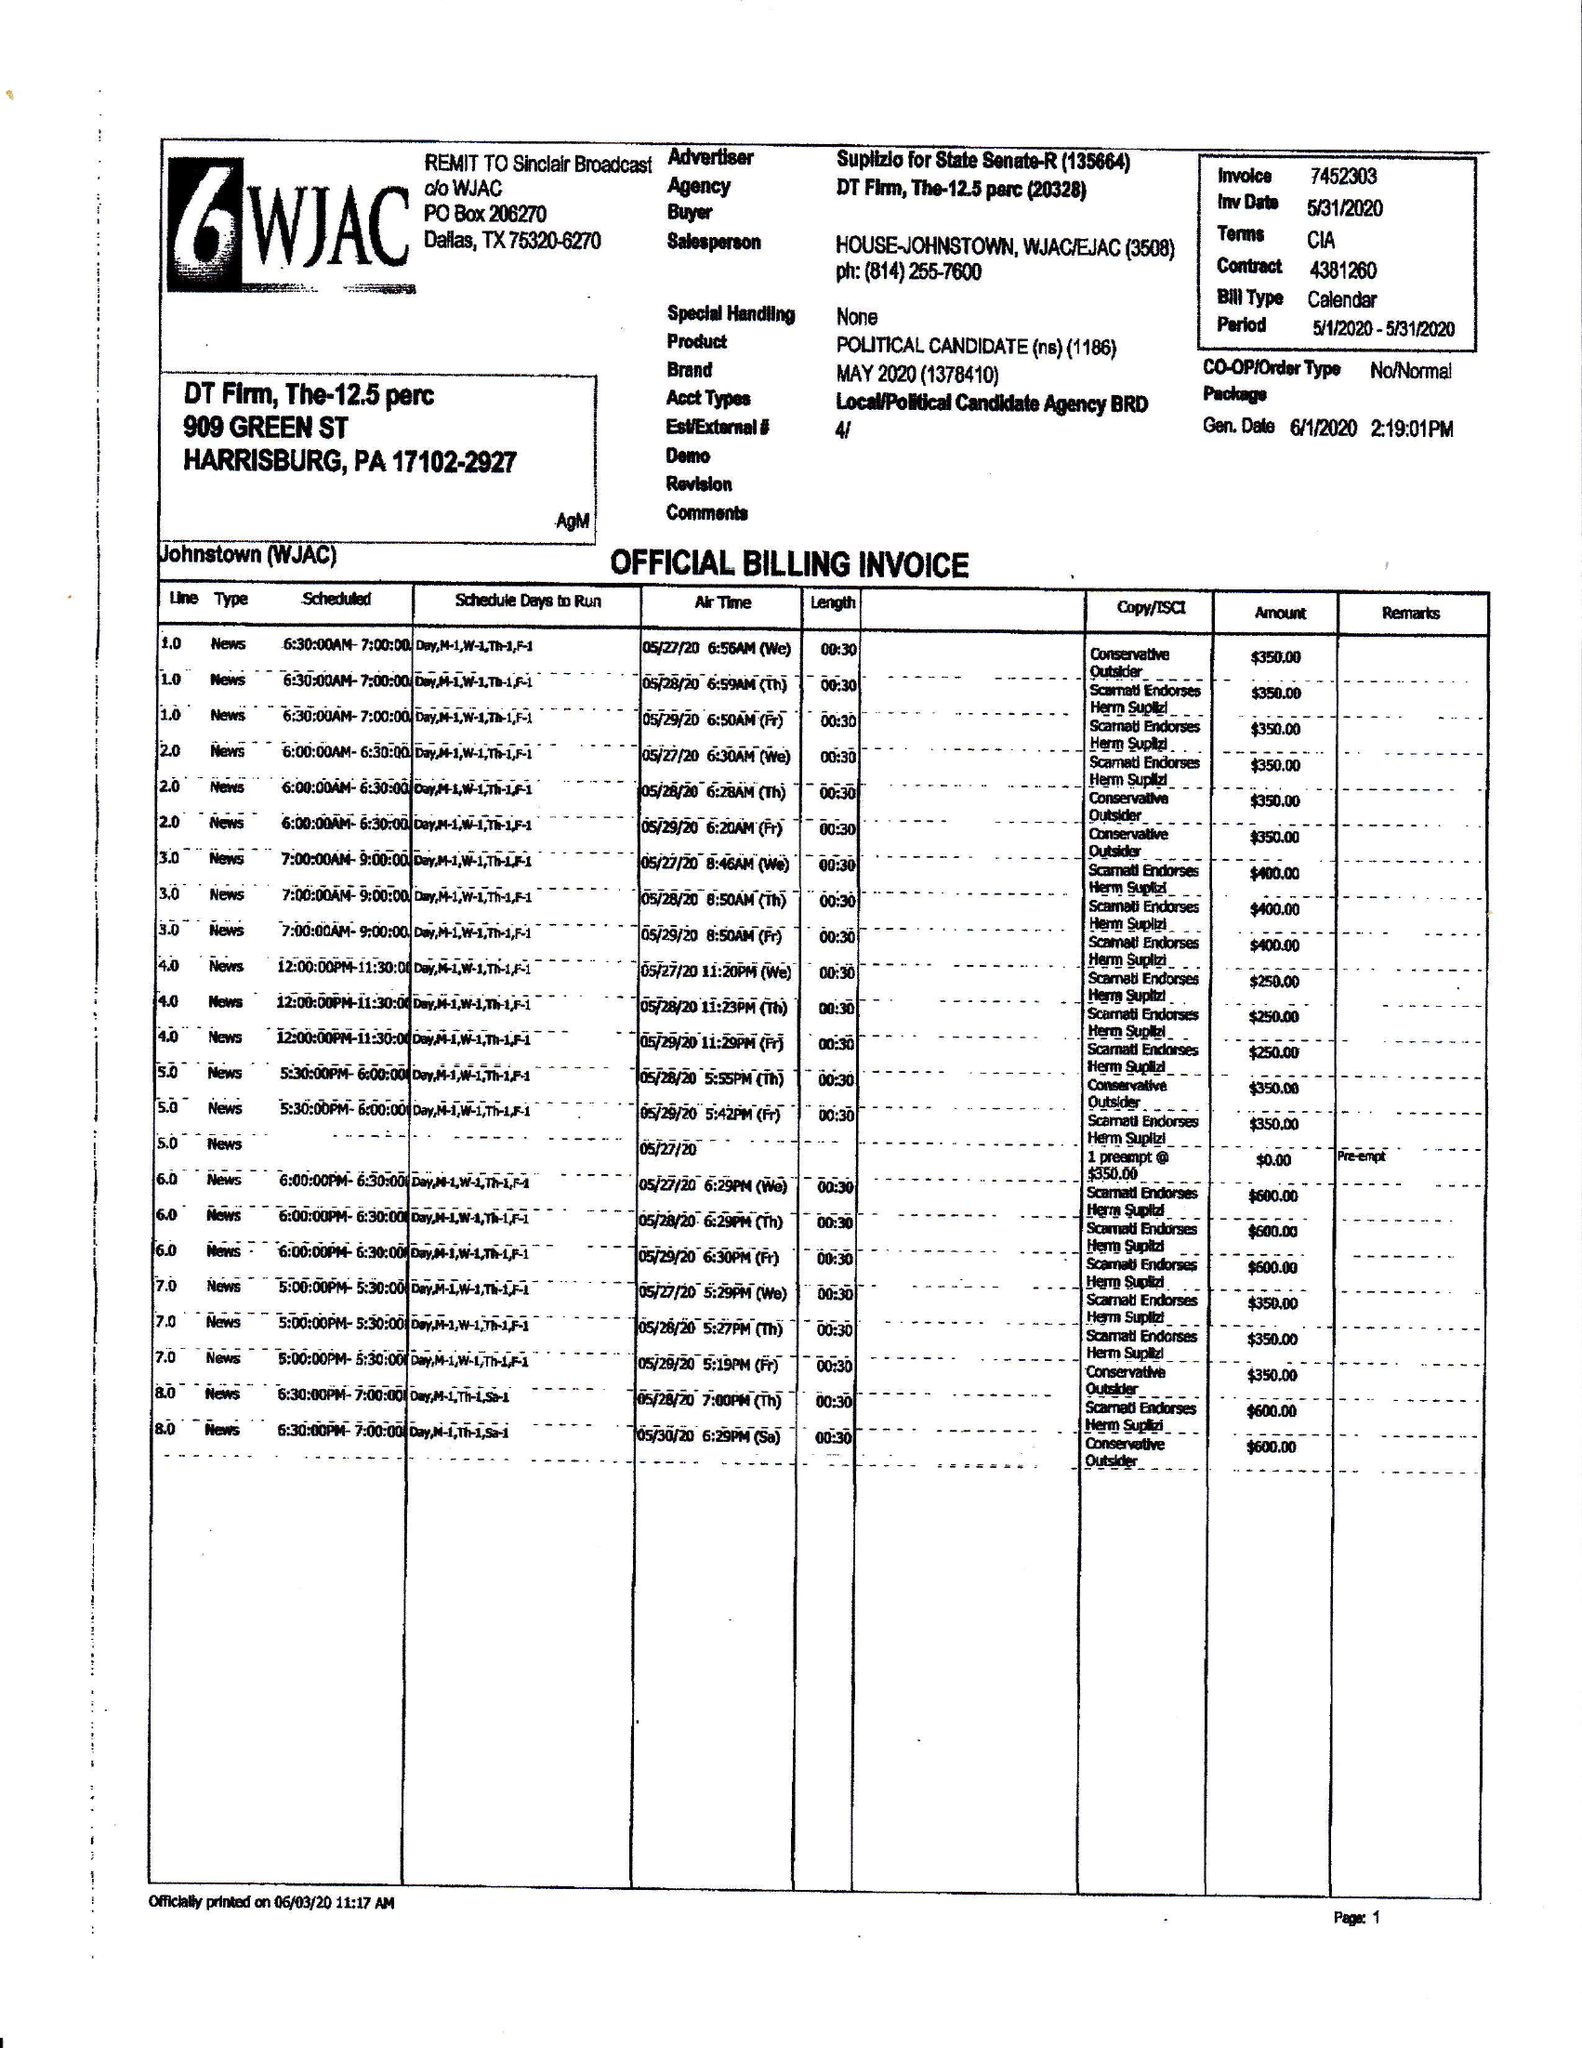What is the value for the flight_from?
Answer the question using a single word or phrase. 05/01/20 